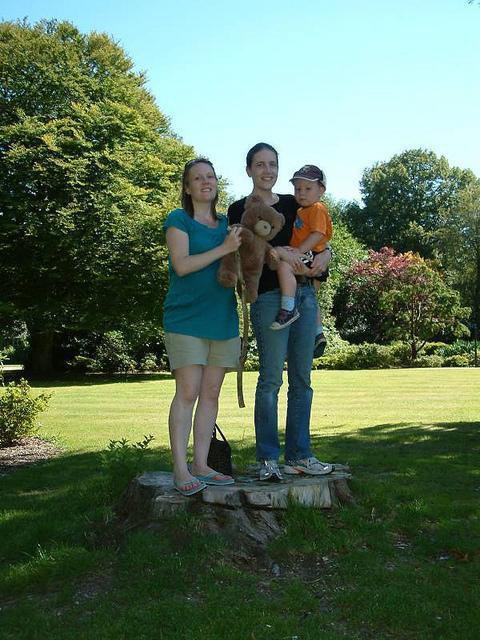How many people are posing for the picture?
Give a very brief answer. 3. How many people are in the picture?
Give a very brief answer. 3. How many umbrellas are there?
Give a very brief answer. 0. 